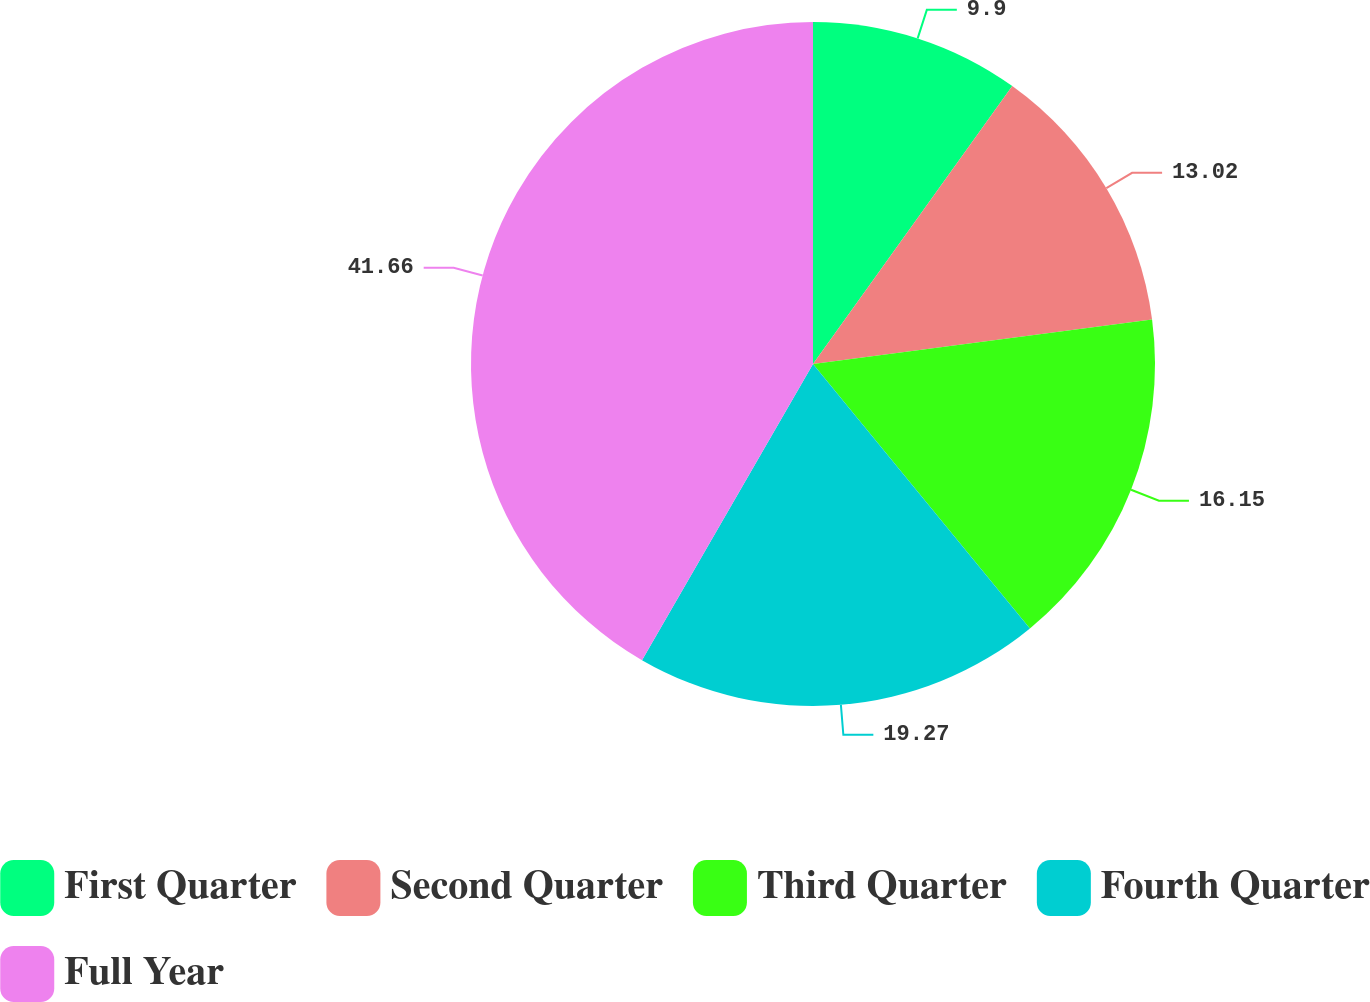<chart> <loc_0><loc_0><loc_500><loc_500><pie_chart><fcel>First Quarter<fcel>Second Quarter<fcel>Third Quarter<fcel>Fourth Quarter<fcel>Full Year<nl><fcel>9.9%<fcel>13.02%<fcel>16.15%<fcel>19.27%<fcel>41.67%<nl></chart> 